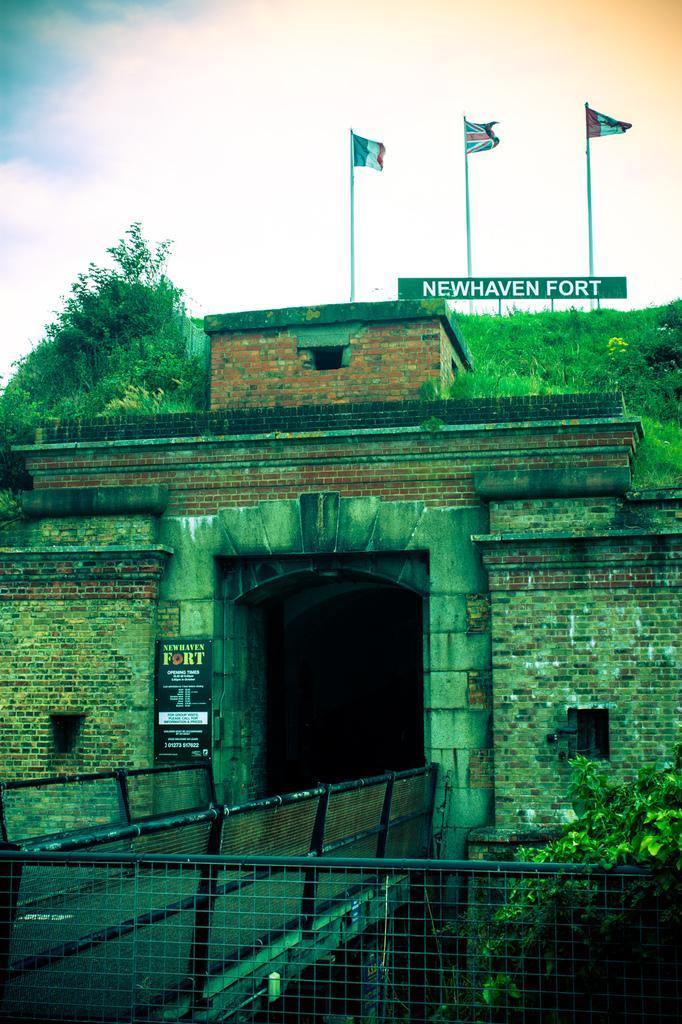Can you describe this image briefly? In this image, we can see a fort and there are trees, flags, boards and there is a bridge and we can see a mesh. At the top, there is sky. 